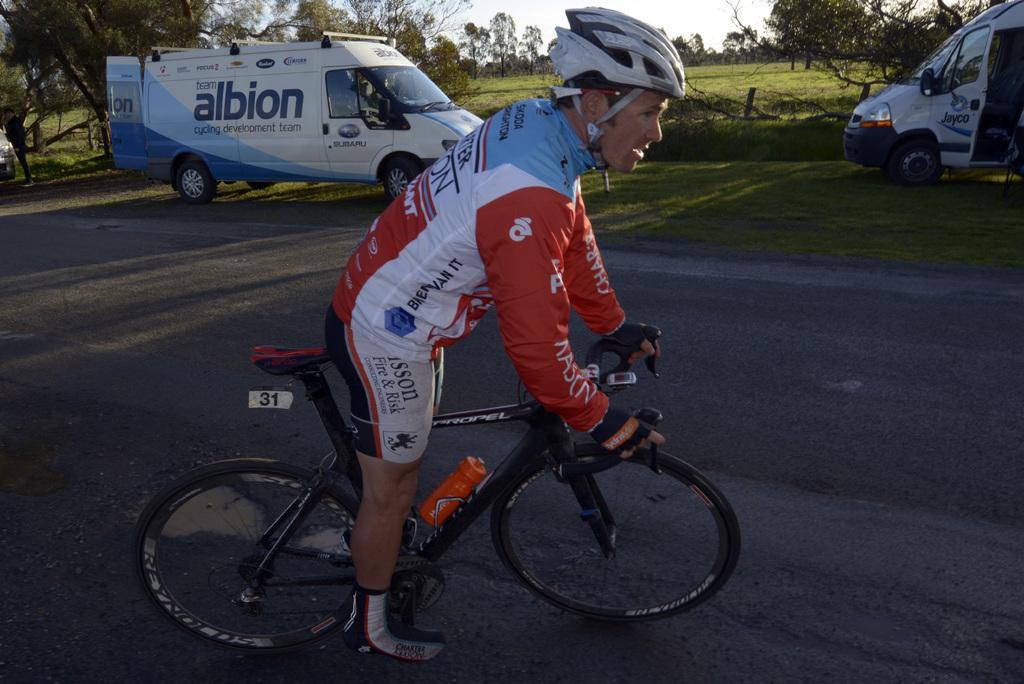Could you give a brief overview of what you see in this image? In this picture there is a man riding bicycle. At the back there are vehicles and there are trees and there is text on the vehicles. At the top there is sky. At the bottom there is a road and there is grass. 